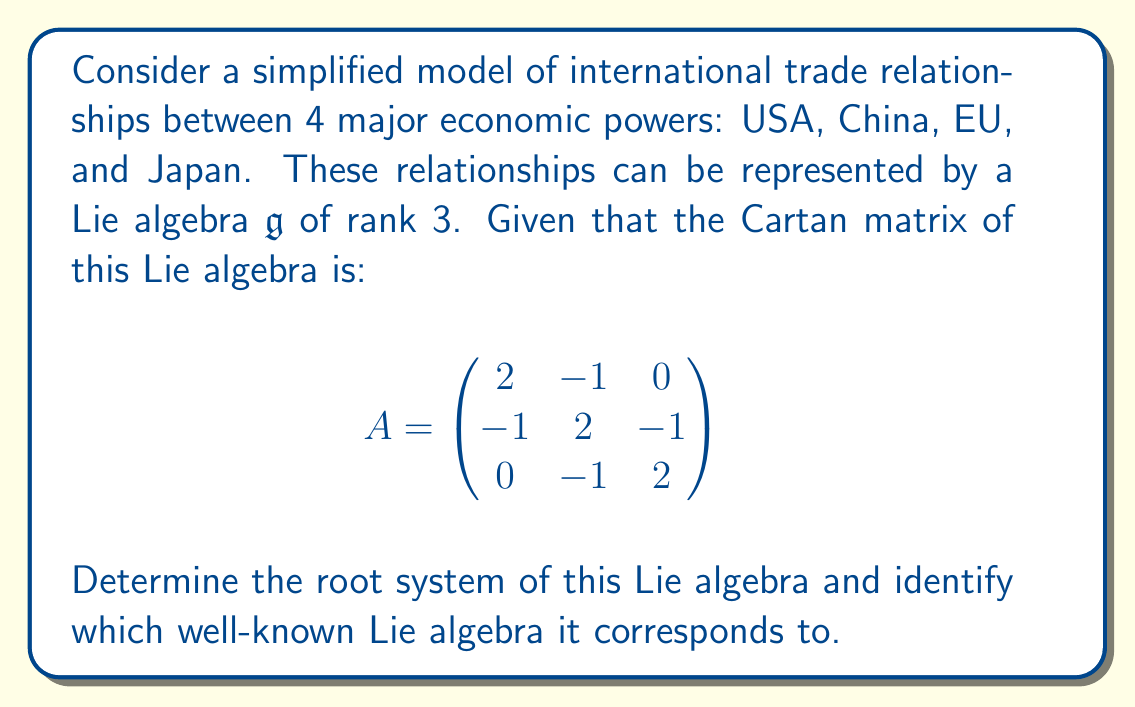Could you help me with this problem? To determine the root system and identify the Lie algebra, we'll follow these steps:

1) First, we recognize that the Cartan matrix corresponds to a rank 3 Lie algebra. The matrix is symmetric, which indicates that this is a simply-laced Lie algebra (all roots have the same length).

2) We can represent the simple roots in a 3-dimensional space. Let's denote them as $\alpha_1$, $\alpha_2$, and $\alpha_3$. We can choose a basis where:

   $\alpha_1 = (1, 0, 0)$
   $\alpha_2 = (-1/2, \sqrt{3}/2, 0)$
   $\alpha_3 = (0, -1/\sqrt{3}, \sqrt{2/3})$

3) These simple roots satisfy the relationships given by the Cartan matrix:

   $(\alpha_i, \alpha_j) = A_{ij}$

4) The positive roots are:
   
   $\alpha_1$, $\alpha_2$, $\alpha_3$
   $\alpha_1 + \alpha_2$, $\alpha_2 + \alpha_3$
   $\alpha_1 + \alpha_2 + \alpha_3$

5) The negative roots are the negatives of these.

6) In total, there are 12 roots (6 positive and 6 negative).

7) This root system forms a regular octahedron in 3D space:

[asy]
import three;
size(200);
currentprojection=perspective(6,3,2);
draw((-1,0,0)--(1,0,0),red,Arrow3);
draw((0,-1,0)--(0,1,0),green,Arrow3);
draw((0,0,-1)--(0,0,1),blue,Arrow3);
dot((1,0,0)); dot((-1,0,0));
dot((0,1,0)); dot((0,-1,0));
dot((0,0,1)); dot((0,0,-1));
label("$\alpha_1$",(1,0,0),E);
label("$\alpha_2$",(0,1,0),N);
label("$\alpha_3$",(0,0,1),Z);
[/asy]

8) This root system and Cartan matrix correspond to the Lie algebra $A_3$, which is isomorphic to $\mathfrak{sl}(4, \mathbb{C})$.

In the context of international trade, this could represent a simplified model where:
- Each simple root represents a primary trade relationship (e.g., USA-China, China-EU, EU-Japan)
- Compound roots represent indirect relationships or effects (e.g., USA-EU via China)
- The symmetry of the system indicates a balanced trade network
Answer: The root system consists of 12 roots forming a regular octahedron in 3D space. This corresponds to the Lie algebra $A_3 \cong \mathfrak{sl}(4, \mathbb{C})$. 